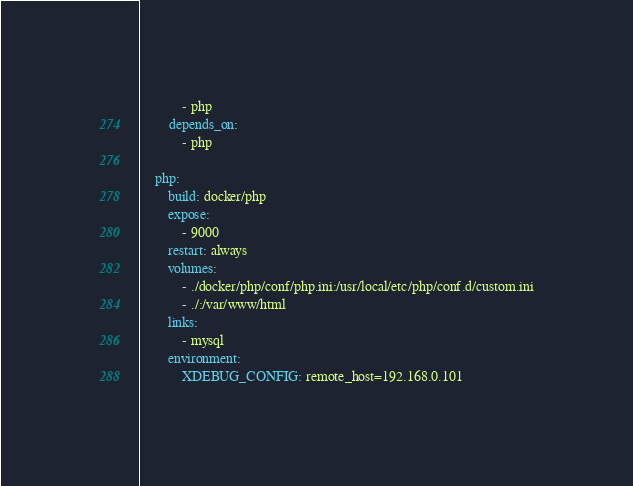<code> <loc_0><loc_0><loc_500><loc_500><_YAML_>            - php
        depends_on:
            - php

    php:
        build: docker/php
        expose:
            - 9000
        restart: always
        volumes:
            - ./docker/php/conf/php.ini:/usr/local/etc/php/conf.d/custom.ini
            - ./:/var/www/html
        links:
            - mysql
        environment:
            XDEBUG_CONFIG: remote_host=192.168.0.101</code> 